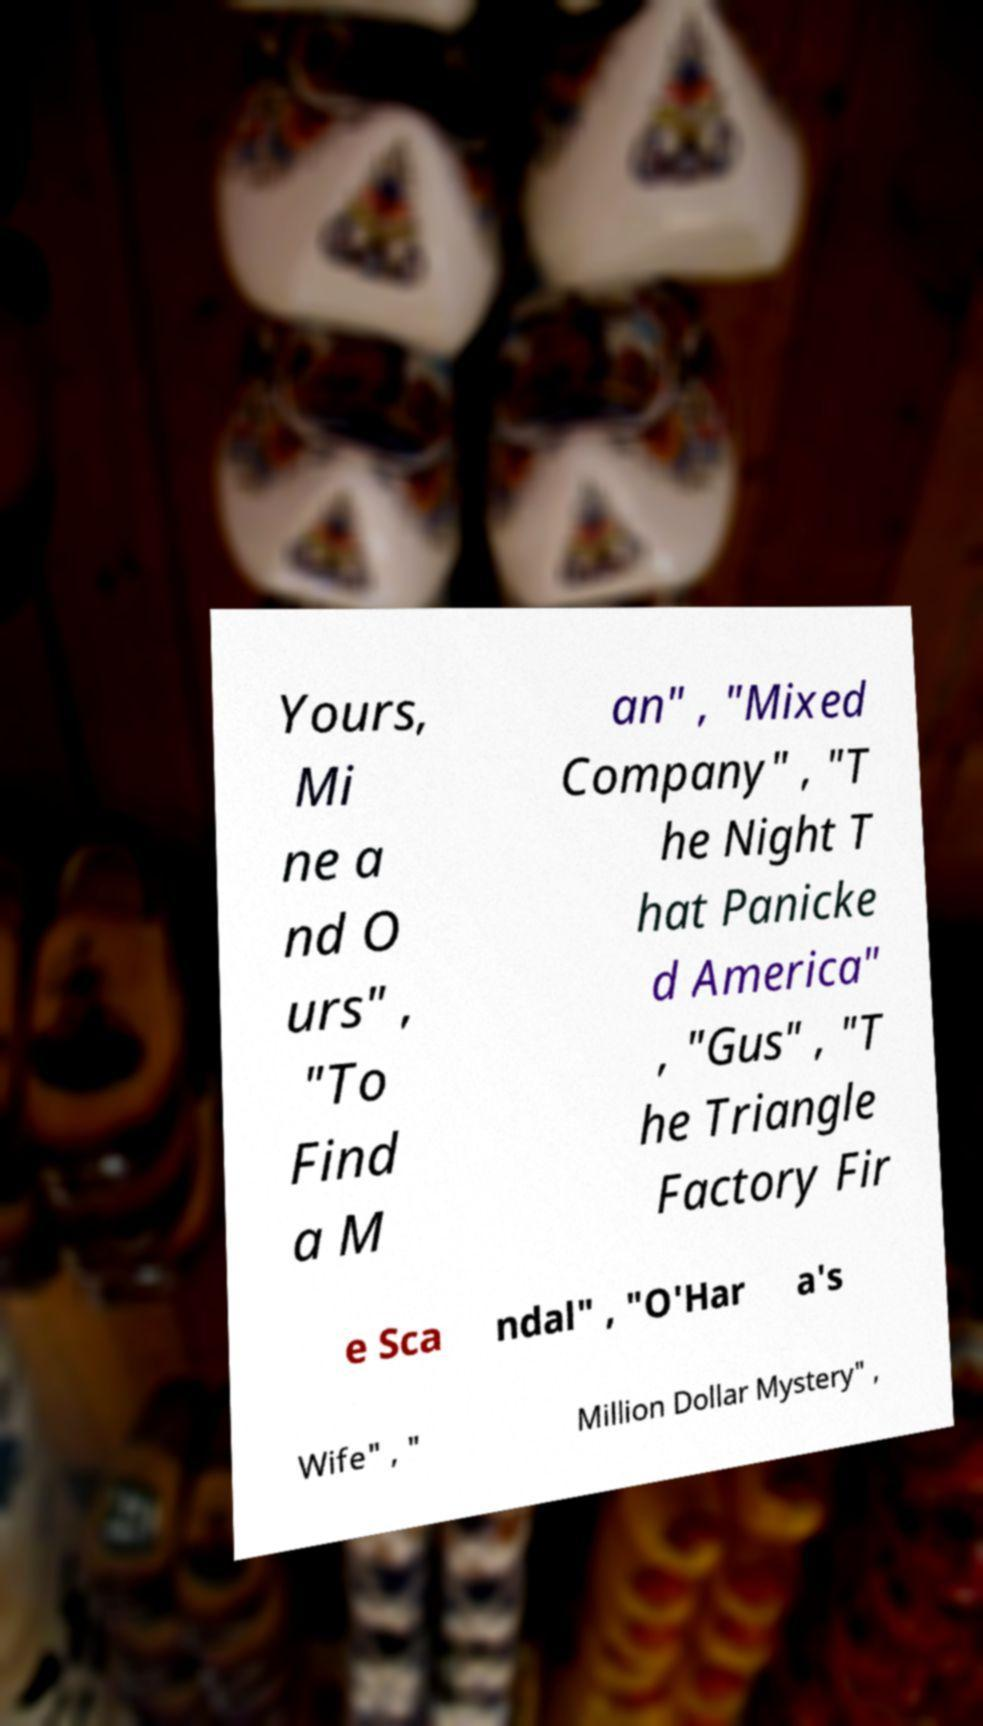I need the written content from this picture converted into text. Can you do that? Yours, Mi ne a nd O urs" , "To Find a M an" , "Mixed Company" , "T he Night T hat Panicke d America" , "Gus" , "T he Triangle Factory Fir e Sca ndal" , "O'Har a's Wife" , " Million Dollar Mystery" , 